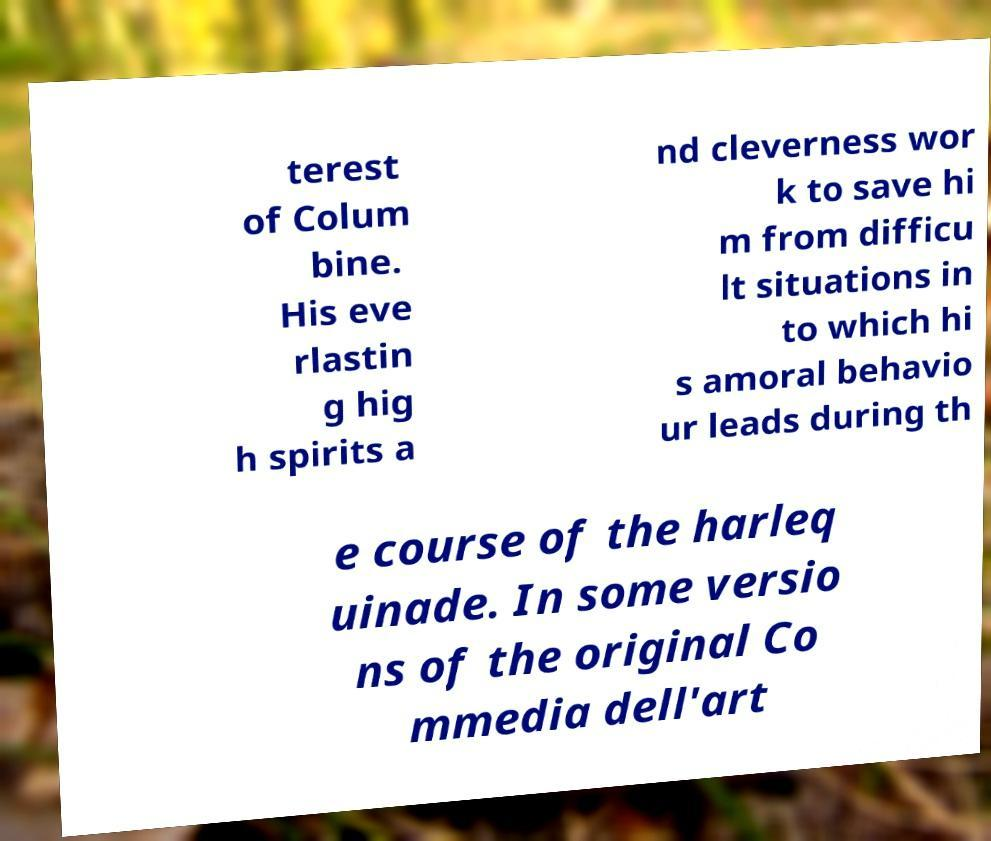Can you accurately transcribe the text from the provided image for me? terest of Colum bine. His eve rlastin g hig h spirits a nd cleverness wor k to save hi m from difficu lt situations in to which hi s amoral behavio ur leads during th e course of the harleq uinade. In some versio ns of the original Co mmedia dell'art 